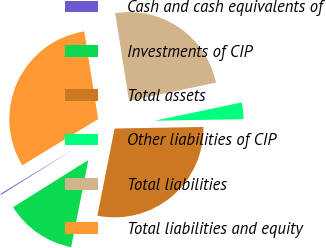<chart> <loc_0><loc_0><loc_500><loc_500><pie_chart><fcel>Cash and cash equivalents of<fcel>Investments of CIP<fcel>Total assets<fcel>Other liabilities of CIP<fcel>Total liabilities<fcel>Total liabilities and equity<nl><fcel>0.2%<fcel>12.99%<fcel>28.39%<fcel>3.02%<fcel>24.2%<fcel>31.21%<nl></chart> 